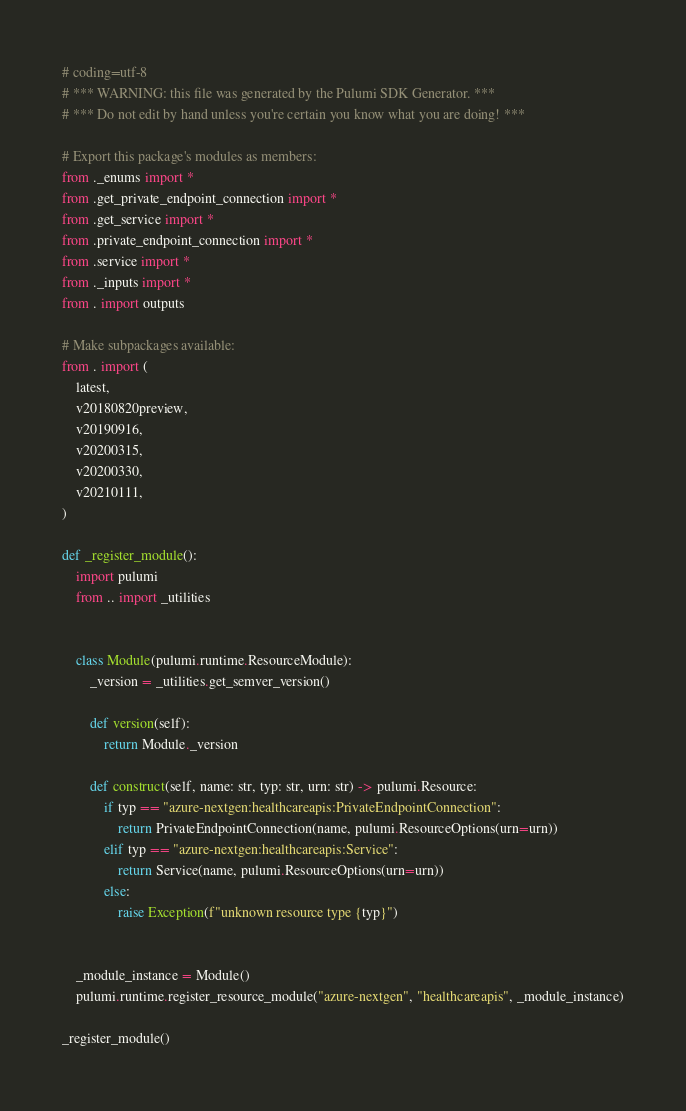Convert code to text. <code><loc_0><loc_0><loc_500><loc_500><_Python_># coding=utf-8
# *** WARNING: this file was generated by the Pulumi SDK Generator. ***
# *** Do not edit by hand unless you're certain you know what you are doing! ***

# Export this package's modules as members:
from ._enums import *
from .get_private_endpoint_connection import *
from .get_service import *
from .private_endpoint_connection import *
from .service import *
from ._inputs import *
from . import outputs

# Make subpackages available:
from . import (
    latest,
    v20180820preview,
    v20190916,
    v20200315,
    v20200330,
    v20210111,
)

def _register_module():
    import pulumi
    from .. import _utilities


    class Module(pulumi.runtime.ResourceModule):
        _version = _utilities.get_semver_version()

        def version(self):
            return Module._version

        def construct(self, name: str, typ: str, urn: str) -> pulumi.Resource:
            if typ == "azure-nextgen:healthcareapis:PrivateEndpointConnection":
                return PrivateEndpointConnection(name, pulumi.ResourceOptions(urn=urn))
            elif typ == "azure-nextgen:healthcareapis:Service":
                return Service(name, pulumi.ResourceOptions(urn=urn))
            else:
                raise Exception(f"unknown resource type {typ}")


    _module_instance = Module()
    pulumi.runtime.register_resource_module("azure-nextgen", "healthcareapis", _module_instance)

_register_module()
</code> 